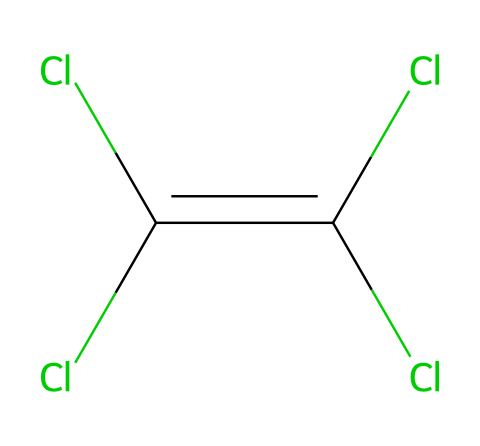What is the common name for the chemical represented by this structure? The structure corresponds to perchloroethylene, which is commonly used as a solvent in dry cleaning and has the name reflecting its chlorine content and the presence of double bonds.
Answer: perchloroethylene How many chlorine atoms are present in this molecule? By examining the chemical structure, we identify a total of four chlorine atoms surrounding the carbon atoms in the double bonded configurations, confirming the presence of four chlorines.
Answer: four What is the total number of carbon atoms in this structure? The structure has two carbon atoms, which are represented in the center of the SMILES notation, with a double bond between them.
Answer: two Which type of chemical bond is primarily represented in the molecule? The double bond between the two carbon atoms is the main focus of the structure, signifying that the molecule contains a carbon-carbon double bond, which is characteristic of unsaturated hydrocarbons.
Answer: double bond Is perchloroethylene classified as a hazardous chemical? Given its properties and usage, perchloroethylene is indeed classified as a hazardous chemical due to its potential health impacts and environmental risks associated with inhalation and exposure.
Answer: yes What type of molecule is represented by this structure based on its usage? The molecule is recognized as an organic solvent, widely utilized for its ability to dissolve other substances, particularly for use in the dry cleaning industry.
Answer: organic solvent 